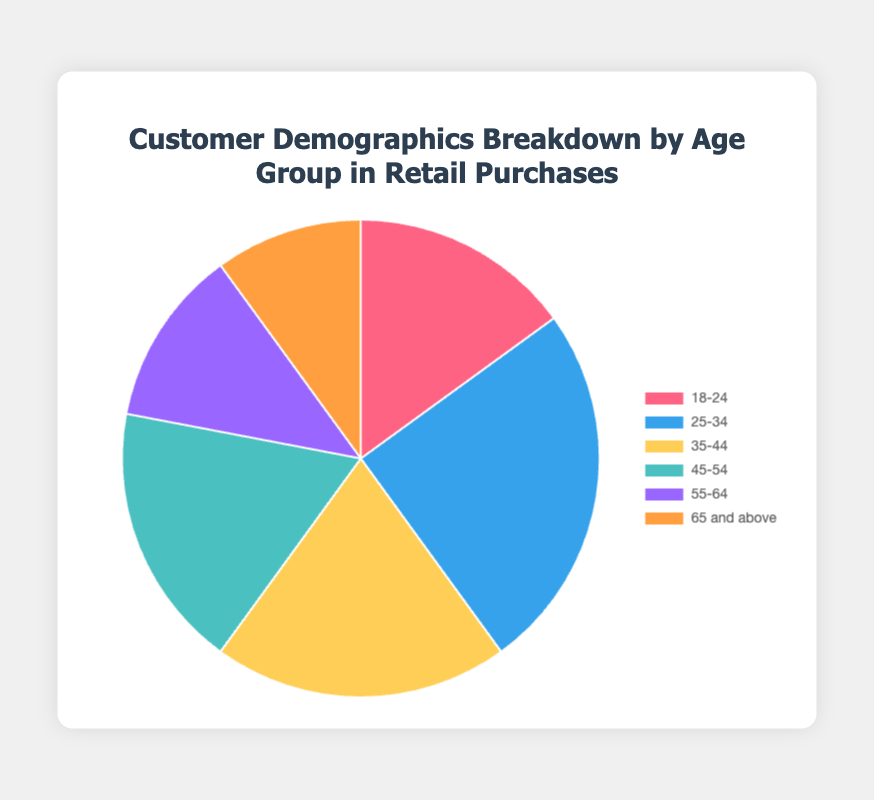Which age group contributes the most to retail purchases? The age group "25-34" contributes the most as it has the largest percentage of purchases at 25%.
Answer: 25-34 What is the total percentage of purchases contributed by customers aged 35-44 and 45-54? To find the total percentage, add the percentages of the "35-44" and "45-54" age groups. So, 20% + 18% = 38%.
Answer: 38% How much higher is the percentage of purchases for the age group 25-34 compared to the age group 55-64? Subtract the percentage of the "55-64" age group from the "25-34" age group. So, 25% - 12% = 13%.
Answer: 13% Which age group has the smallest proportion of retail purchases? The "65 and above" age group has the smallest proportion of retail purchases at 10%.
Answer: 65 and above By inspecting the pie chart, what color represents the age group 18-24? The color representing the age group "18-24" on the pie chart is red.
Answer: red What is the combined percentage of purchases made by customers aged 18-24, 55-64, and 65 and above? Add the percentages of the "18-24", "55-64", and "65 and above" age groups. So, 15% + 12% + 10% = 37%.
Answer: 37% Compare the percentages of purchases for the age group 25-34 and 35-44. Which one is higher and by how much? The "25-34" age group is higher. Subtract the "35-44" percentage from the "25-34" percentage. So, 25% - 20% = 5%.
Answer: 25-34 by 5% Does the age group 45-54 contribute more or less than 20% of the purchases? The age group "45-54" contributes less than 20% of the purchases since it accounts for only 18%.
Answer: Less What visual attribute differentiates the age group 55-64 from other groups in the pie chart? The age group "55-64" is represented by the color purple on the pie chart.
Answer: purple 